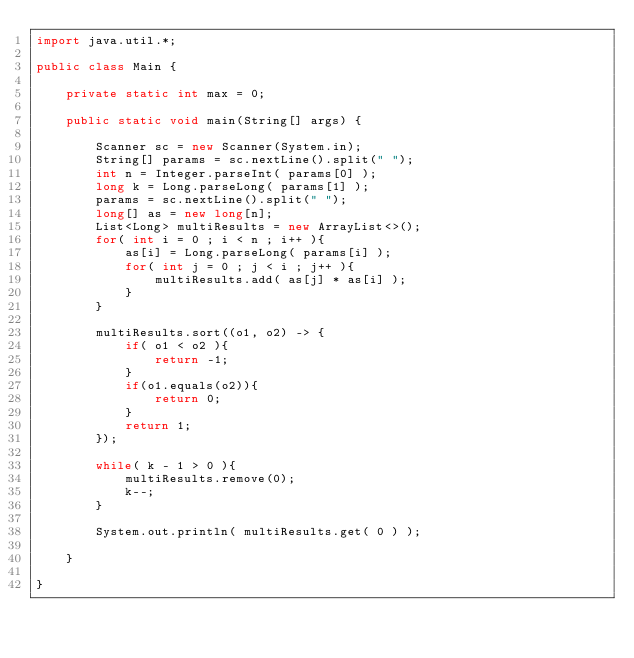<code> <loc_0><loc_0><loc_500><loc_500><_Java_>import java.util.*;

public class Main {

    private static int max = 0;

    public static void main(String[] args) {

        Scanner sc = new Scanner(System.in);
        String[] params = sc.nextLine().split(" ");
        int n = Integer.parseInt( params[0] );
        long k = Long.parseLong( params[1] );
        params = sc.nextLine().split(" ");
        long[] as = new long[n];
        List<Long> multiResults = new ArrayList<>();
        for( int i = 0 ; i < n ; i++ ){
            as[i] = Long.parseLong( params[i] );
            for( int j = 0 ; j < i ; j++ ){
                multiResults.add( as[j] * as[i] );
            }
        }

        multiResults.sort((o1, o2) -> {
            if( o1 < o2 ){
                return -1;
            }
            if(o1.equals(o2)){
                return 0;
            }
            return 1;
        });

        while( k - 1 > 0 ){
            multiResults.remove(0);
            k--;
        }

        System.out.println( multiResults.get( 0 ) );

    }

}
</code> 